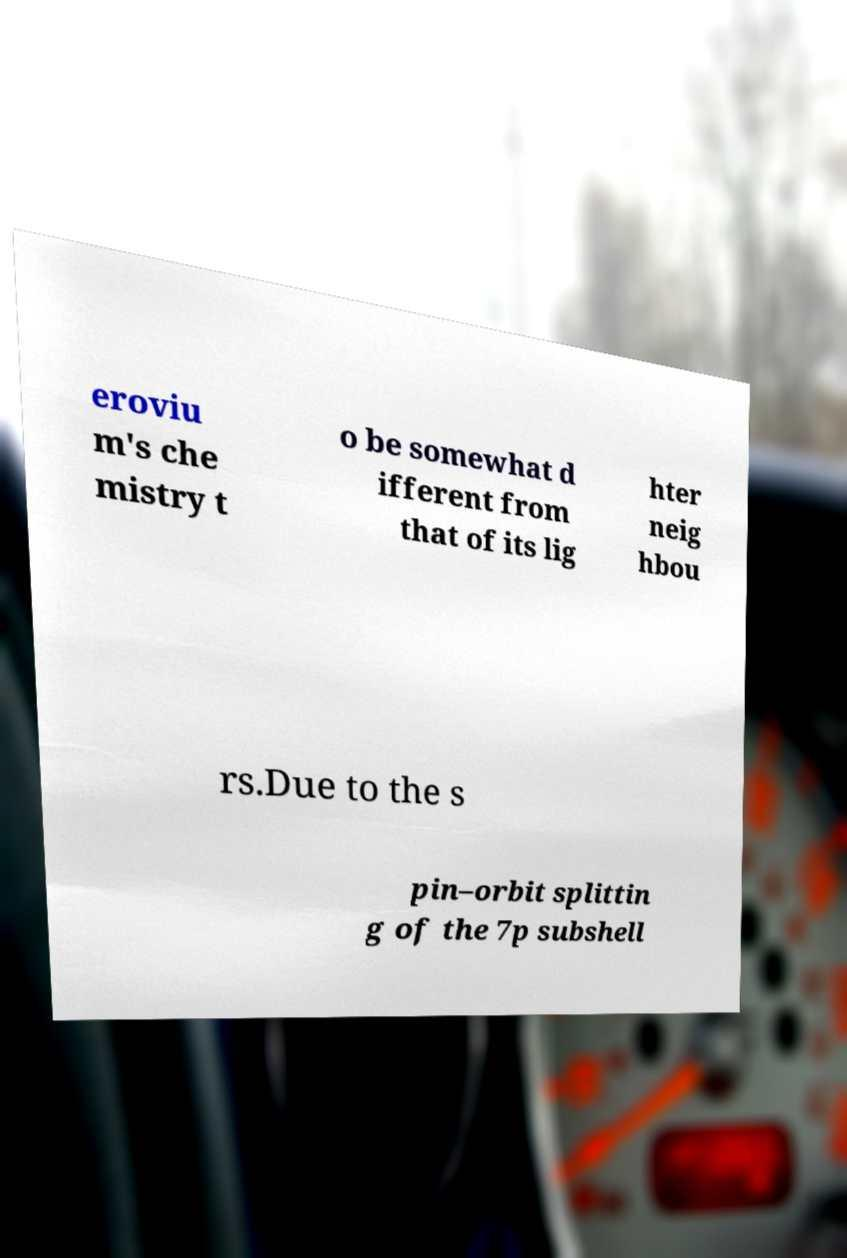Can you accurately transcribe the text from the provided image for me? eroviu m's che mistry t o be somewhat d ifferent from that of its lig hter neig hbou rs.Due to the s pin–orbit splittin g of the 7p subshell 